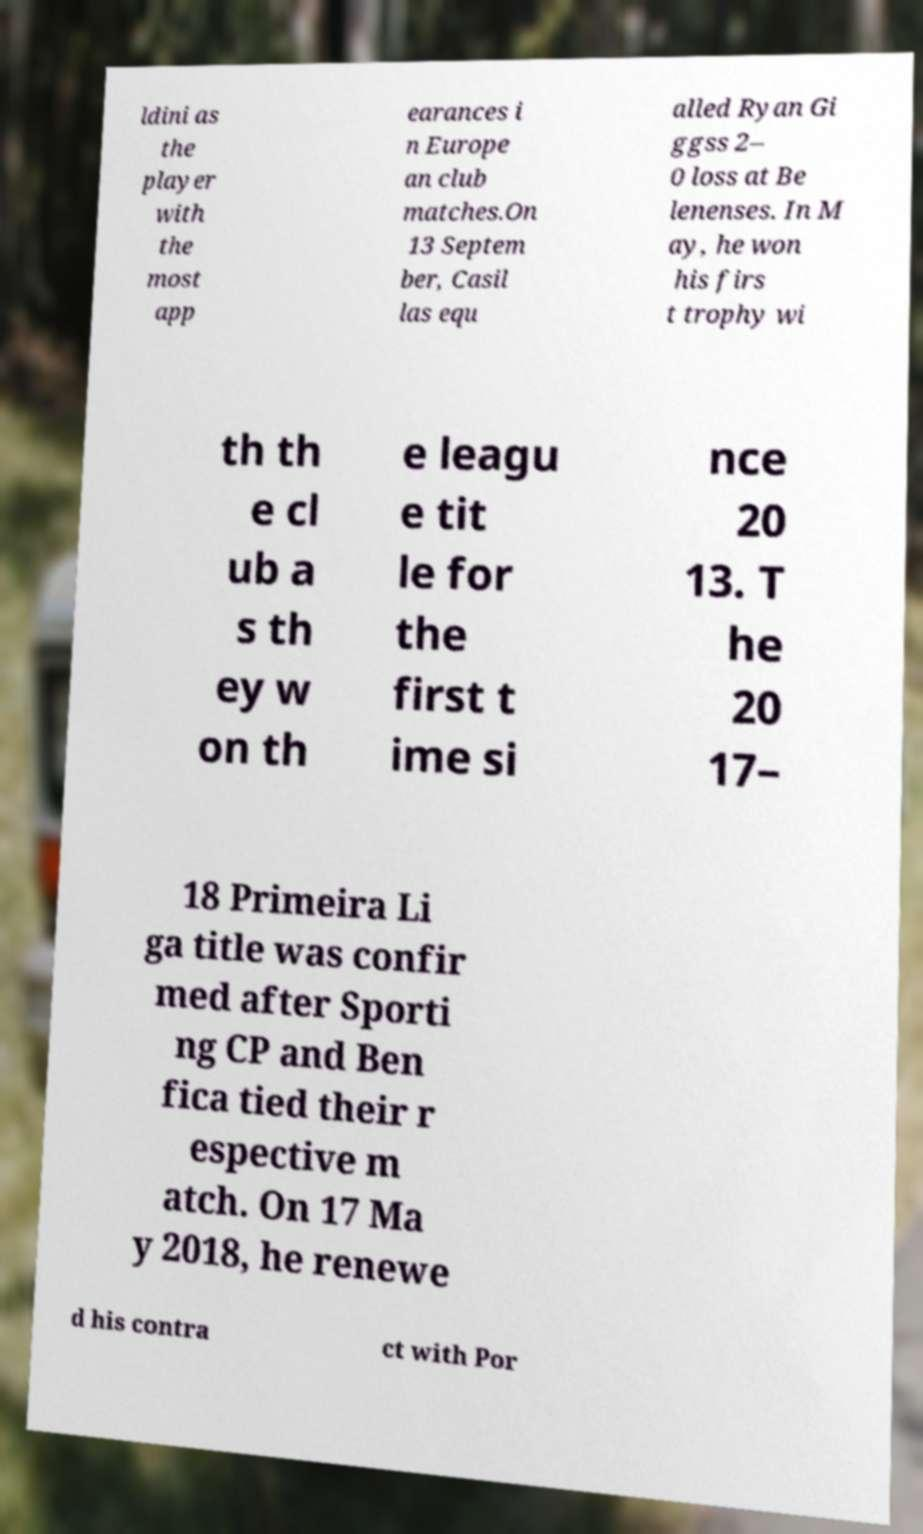I need the written content from this picture converted into text. Can you do that? ldini as the player with the most app earances i n Europe an club matches.On 13 Septem ber, Casil las equ alled Ryan Gi ggss 2– 0 loss at Be lenenses. In M ay, he won his firs t trophy wi th th e cl ub a s th ey w on th e leagu e tit le for the first t ime si nce 20 13. T he 20 17– 18 Primeira Li ga title was confir med after Sporti ng CP and Ben fica tied their r espective m atch. On 17 Ma y 2018, he renewe d his contra ct with Por 